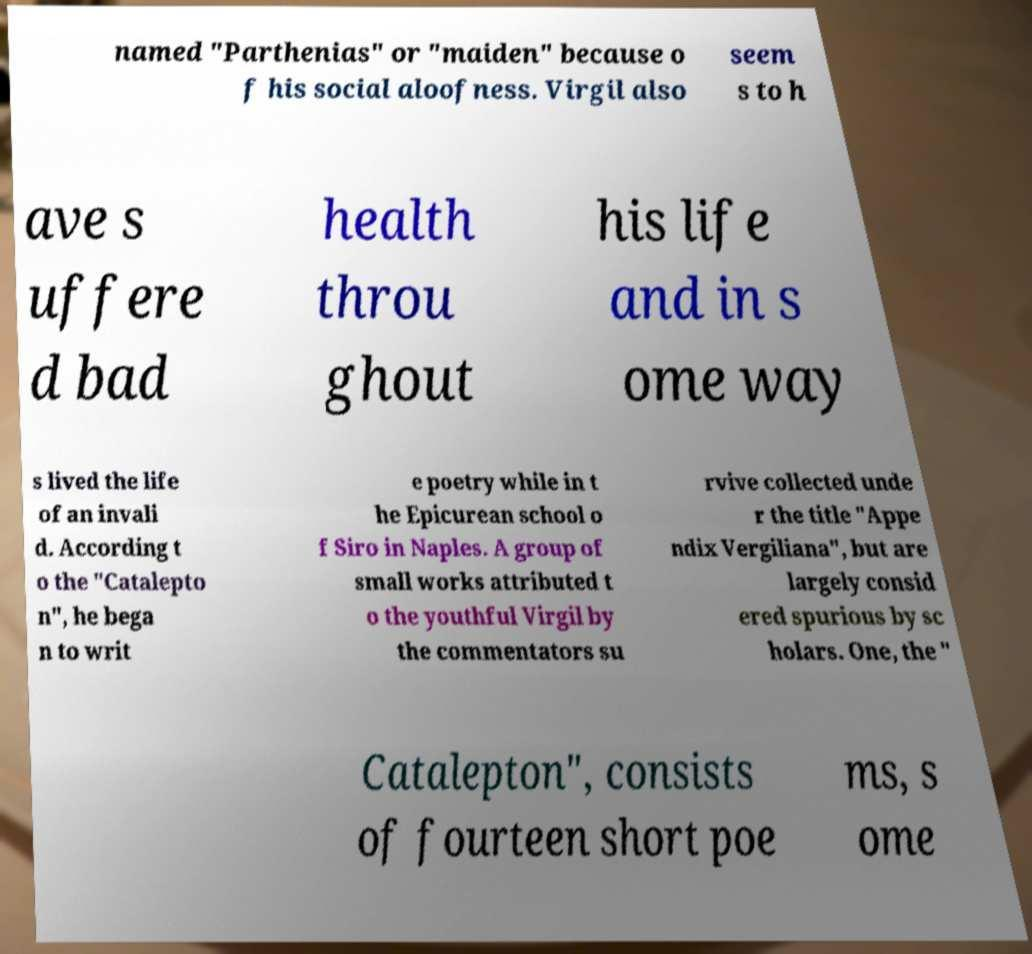Please identify and transcribe the text found in this image. named "Parthenias" or "maiden" because o f his social aloofness. Virgil also seem s to h ave s uffere d bad health throu ghout his life and in s ome way s lived the life of an invali d. According t o the "Catalepto n", he bega n to writ e poetry while in t he Epicurean school o f Siro in Naples. A group of small works attributed t o the youthful Virgil by the commentators su rvive collected unde r the title "Appe ndix Vergiliana", but are largely consid ered spurious by sc holars. One, the " Catalepton", consists of fourteen short poe ms, s ome 